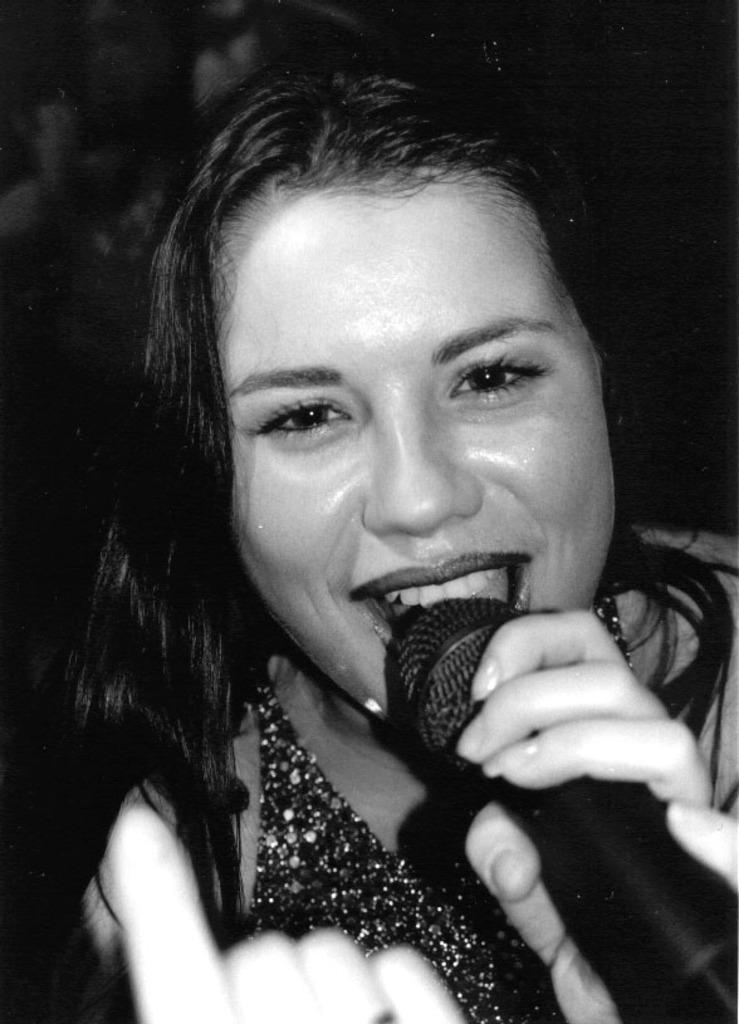Describe this image in one or two sentences. This is a black and white image and here we can see a lady holding a mic. 